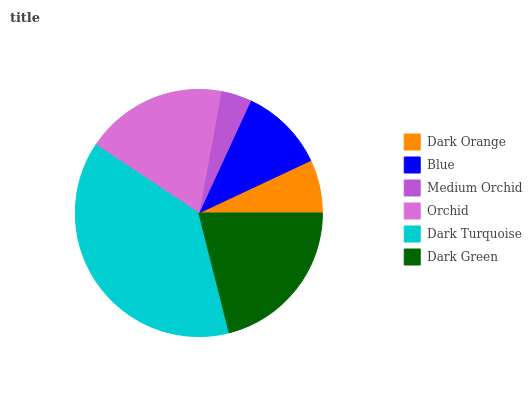Is Medium Orchid the minimum?
Answer yes or no. Yes. Is Dark Turquoise the maximum?
Answer yes or no. Yes. Is Blue the minimum?
Answer yes or no. No. Is Blue the maximum?
Answer yes or no. No. Is Blue greater than Dark Orange?
Answer yes or no. Yes. Is Dark Orange less than Blue?
Answer yes or no. Yes. Is Dark Orange greater than Blue?
Answer yes or no. No. Is Blue less than Dark Orange?
Answer yes or no. No. Is Orchid the high median?
Answer yes or no. Yes. Is Blue the low median?
Answer yes or no. Yes. Is Medium Orchid the high median?
Answer yes or no. No. Is Medium Orchid the low median?
Answer yes or no. No. 